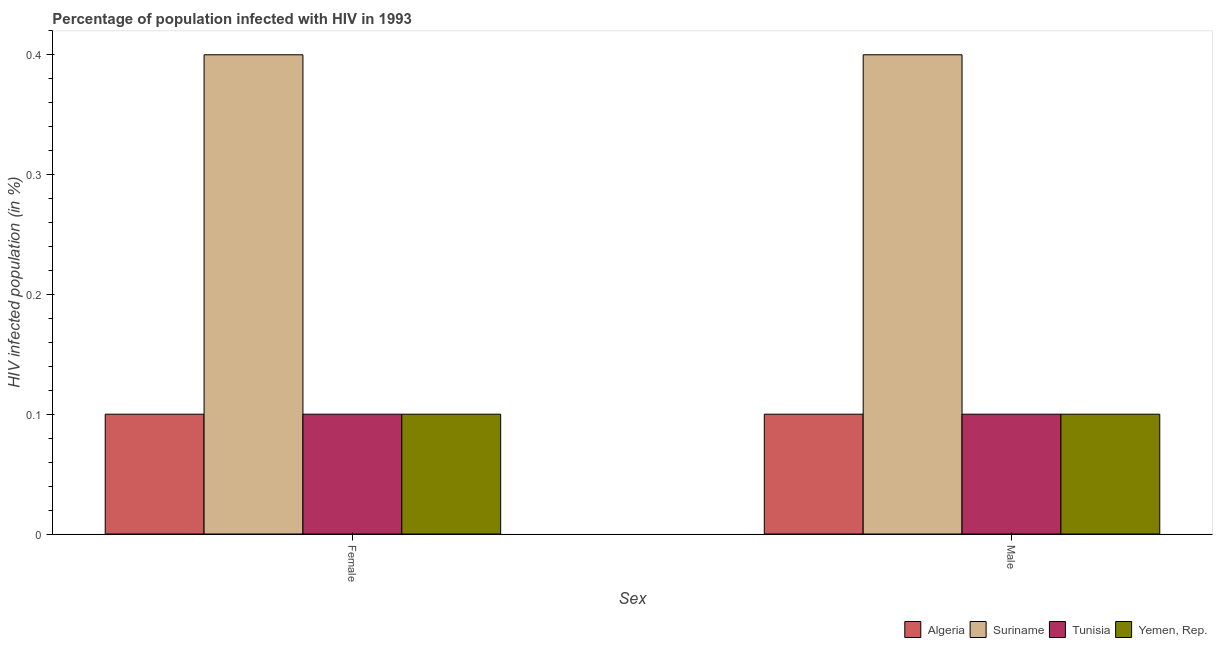How many different coloured bars are there?
Your answer should be compact. 4. How many groups of bars are there?
Your response must be concise. 2. Are the number of bars per tick equal to the number of legend labels?
Ensure brevity in your answer.  Yes. Are the number of bars on each tick of the X-axis equal?
Your response must be concise. Yes. How many bars are there on the 1st tick from the left?
Provide a short and direct response. 4. How many bars are there on the 1st tick from the right?
Keep it short and to the point. 4. What is the label of the 1st group of bars from the left?
Your answer should be compact. Female. What is the percentage of females who are infected with hiv in Yemen, Rep.?
Your response must be concise. 0.1. Across all countries, what is the maximum percentage of females who are infected with hiv?
Your response must be concise. 0.4. Across all countries, what is the minimum percentage of females who are infected with hiv?
Offer a very short reply. 0.1. In which country was the percentage of males who are infected with hiv maximum?
Give a very brief answer. Suriname. In which country was the percentage of males who are infected with hiv minimum?
Provide a succinct answer. Algeria. What is the total percentage of males who are infected with hiv in the graph?
Your answer should be compact. 0.7. What is the difference between the percentage of females who are infected with hiv in Algeria and that in Tunisia?
Ensure brevity in your answer.  0. What is the difference between the percentage of females who are infected with hiv in Tunisia and the percentage of males who are infected with hiv in Suriname?
Your answer should be compact. -0.3. What is the average percentage of males who are infected with hiv per country?
Your answer should be very brief. 0.17. In how many countries, is the percentage of females who are infected with hiv greater than 0.18 %?
Make the answer very short. 1. What is the ratio of the percentage of males who are infected with hiv in Tunisia to that in Suriname?
Your answer should be compact. 0.25. Is the percentage of females who are infected with hiv in Tunisia less than that in Algeria?
Give a very brief answer. No. In how many countries, is the percentage of males who are infected with hiv greater than the average percentage of males who are infected with hiv taken over all countries?
Make the answer very short. 1. What does the 1st bar from the left in Male represents?
Give a very brief answer. Algeria. What does the 3rd bar from the right in Male represents?
Keep it short and to the point. Suriname. How many bars are there?
Your response must be concise. 8. Does the graph contain any zero values?
Provide a short and direct response. No. Does the graph contain grids?
Your answer should be compact. No. How are the legend labels stacked?
Your answer should be compact. Horizontal. What is the title of the graph?
Give a very brief answer. Percentage of population infected with HIV in 1993. Does "Middle East & North Africa (developing only)" appear as one of the legend labels in the graph?
Provide a succinct answer. No. What is the label or title of the X-axis?
Provide a succinct answer. Sex. What is the label or title of the Y-axis?
Keep it short and to the point. HIV infected population (in %). What is the HIV infected population (in %) of Algeria in Female?
Your answer should be very brief. 0.1. What is the HIV infected population (in %) of Suriname in Female?
Your answer should be compact. 0.4. What is the HIV infected population (in %) in Tunisia in Female?
Ensure brevity in your answer.  0.1. What is the HIV infected population (in %) of Yemen, Rep. in Female?
Make the answer very short. 0.1. What is the HIV infected population (in %) of Algeria in Male?
Provide a succinct answer. 0.1. What is the HIV infected population (in %) of Suriname in Male?
Your answer should be compact. 0.4. What is the HIV infected population (in %) of Yemen, Rep. in Male?
Offer a very short reply. 0.1. Across all Sex, what is the maximum HIV infected population (in %) in Algeria?
Ensure brevity in your answer.  0.1. Across all Sex, what is the maximum HIV infected population (in %) of Suriname?
Keep it short and to the point. 0.4. Across all Sex, what is the maximum HIV infected population (in %) of Tunisia?
Make the answer very short. 0.1. Across all Sex, what is the maximum HIV infected population (in %) of Yemen, Rep.?
Your answer should be very brief. 0.1. Across all Sex, what is the minimum HIV infected population (in %) in Algeria?
Offer a terse response. 0.1. Across all Sex, what is the minimum HIV infected population (in %) of Suriname?
Offer a very short reply. 0.4. Across all Sex, what is the minimum HIV infected population (in %) of Tunisia?
Keep it short and to the point. 0.1. What is the total HIV infected population (in %) in Tunisia in the graph?
Keep it short and to the point. 0.2. What is the total HIV infected population (in %) in Yemen, Rep. in the graph?
Make the answer very short. 0.2. What is the difference between the HIV infected population (in %) of Algeria in Female and that in Male?
Ensure brevity in your answer.  0. What is the difference between the HIV infected population (in %) of Tunisia in Female and that in Male?
Provide a succinct answer. 0. What is the difference between the HIV infected population (in %) in Yemen, Rep. in Female and that in Male?
Give a very brief answer. 0. What is the difference between the HIV infected population (in %) in Algeria in Female and the HIV infected population (in %) in Suriname in Male?
Your response must be concise. -0.3. What is the difference between the HIV infected population (in %) in Algeria in Female and the HIV infected population (in %) in Tunisia in Male?
Your answer should be compact. 0. What is the difference between the HIV infected population (in %) in Algeria in Female and the HIV infected population (in %) in Yemen, Rep. in Male?
Offer a very short reply. 0. What is the difference between the HIV infected population (in %) in Suriname in Female and the HIV infected population (in %) in Tunisia in Male?
Offer a very short reply. 0.3. What is the difference between the HIV infected population (in %) of Suriname in Female and the HIV infected population (in %) of Yemen, Rep. in Male?
Provide a succinct answer. 0.3. What is the average HIV infected population (in %) of Algeria per Sex?
Provide a succinct answer. 0.1. What is the average HIV infected population (in %) in Suriname per Sex?
Make the answer very short. 0.4. What is the average HIV infected population (in %) in Tunisia per Sex?
Ensure brevity in your answer.  0.1. What is the difference between the HIV infected population (in %) in Algeria and HIV infected population (in %) in Suriname in Female?
Ensure brevity in your answer.  -0.3. What is the difference between the HIV infected population (in %) of Algeria and HIV infected population (in %) of Tunisia in Female?
Your answer should be very brief. 0. What is the difference between the HIV infected population (in %) of Suriname and HIV infected population (in %) of Tunisia in Female?
Provide a short and direct response. 0.3. What is the difference between the HIV infected population (in %) of Algeria and HIV infected population (in %) of Suriname in Male?
Ensure brevity in your answer.  -0.3. What is the difference between the HIV infected population (in %) of Algeria and HIV infected population (in %) of Tunisia in Male?
Ensure brevity in your answer.  0. What is the difference between the HIV infected population (in %) in Suriname and HIV infected population (in %) in Yemen, Rep. in Male?
Your answer should be very brief. 0.3. What is the ratio of the HIV infected population (in %) of Suriname in Female to that in Male?
Offer a very short reply. 1. What is the ratio of the HIV infected population (in %) of Tunisia in Female to that in Male?
Ensure brevity in your answer.  1. What is the ratio of the HIV infected population (in %) in Yemen, Rep. in Female to that in Male?
Offer a terse response. 1. What is the difference between the highest and the second highest HIV infected population (in %) of Algeria?
Keep it short and to the point. 0. What is the difference between the highest and the second highest HIV infected population (in %) of Suriname?
Offer a very short reply. 0. What is the difference between the highest and the second highest HIV infected population (in %) of Tunisia?
Give a very brief answer. 0. What is the difference between the highest and the second highest HIV infected population (in %) of Yemen, Rep.?
Provide a short and direct response. 0. What is the difference between the highest and the lowest HIV infected population (in %) of Algeria?
Make the answer very short. 0. What is the difference between the highest and the lowest HIV infected population (in %) in Tunisia?
Keep it short and to the point. 0. What is the difference between the highest and the lowest HIV infected population (in %) of Yemen, Rep.?
Give a very brief answer. 0. 